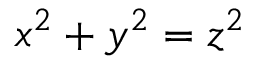<formula> <loc_0><loc_0><loc_500><loc_500>x ^ { 2 } + y ^ { 2 } = z ^ { 2 }</formula> 